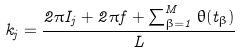Convert formula to latex. <formula><loc_0><loc_0><loc_500><loc_500>k _ { j } = \frac { 2 \pi I _ { j } + 2 \pi f + \sum ^ { M } _ { \beta = 1 } \theta ( t _ { \beta } ) } { L }</formula> 